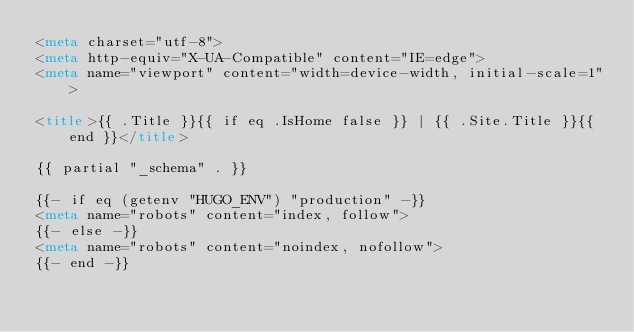<code> <loc_0><loc_0><loc_500><loc_500><_HTML_><meta charset="utf-8">
<meta http-equiv="X-UA-Compatible" content="IE=edge">
<meta name="viewport" content="width=device-width, initial-scale=1">

<title>{{ .Title }}{{ if eq .IsHome false }} | {{ .Site.Title }}{{ end }}</title>

{{ partial "_schema" . }}

{{- if eq (getenv "HUGO_ENV") "production" -}}
<meta name="robots" content="index, follow">
{{- else -}}
<meta name="robots" content="noindex, nofollow">
{{- end -}}</code> 